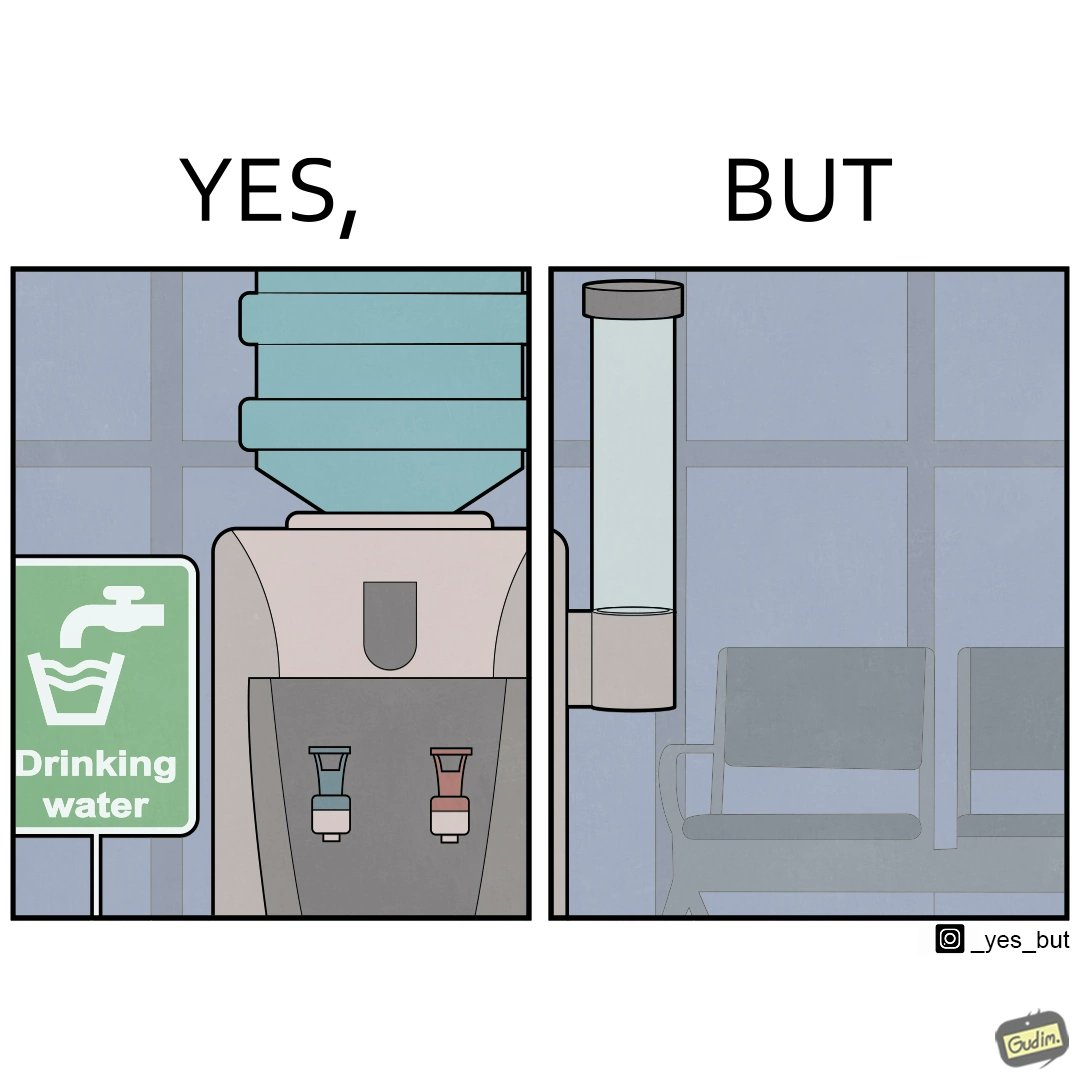Why is this image considered satirical? The images are funny since they show how a workspace has installed drinking water dispenser but it is of no use since the water cup dispenser is left empty 